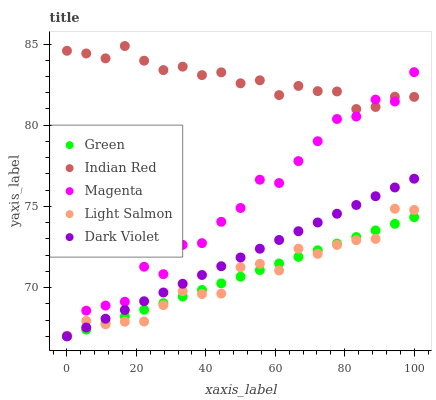Does Light Salmon have the minimum area under the curve?
Answer yes or no. Yes. Does Indian Red have the maximum area under the curve?
Answer yes or no. Yes. Does Magenta have the minimum area under the curve?
Answer yes or no. No. Does Magenta have the maximum area under the curve?
Answer yes or no. No. Is Dark Violet the smoothest?
Answer yes or no. Yes. Is Magenta the roughest?
Answer yes or no. Yes. Is Green the smoothest?
Answer yes or no. No. Is Green the roughest?
Answer yes or no. No. Does Dark Violet have the lowest value?
Answer yes or no. Yes. Does Light Salmon have the lowest value?
Answer yes or no. No. Does Indian Red have the highest value?
Answer yes or no. Yes. Does Magenta have the highest value?
Answer yes or no. No. Is Light Salmon less than Indian Red?
Answer yes or no. Yes. Is Indian Red greater than Dark Violet?
Answer yes or no. Yes. Does Light Salmon intersect Dark Violet?
Answer yes or no. Yes. Is Light Salmon less than Dark Violet?
Answer yes or no. No. Is Light Salmon greater than Dark Violet?
Answer yes or no. No. Does Light Salmon intersect Indian Red?
Answer yes or no. No. 